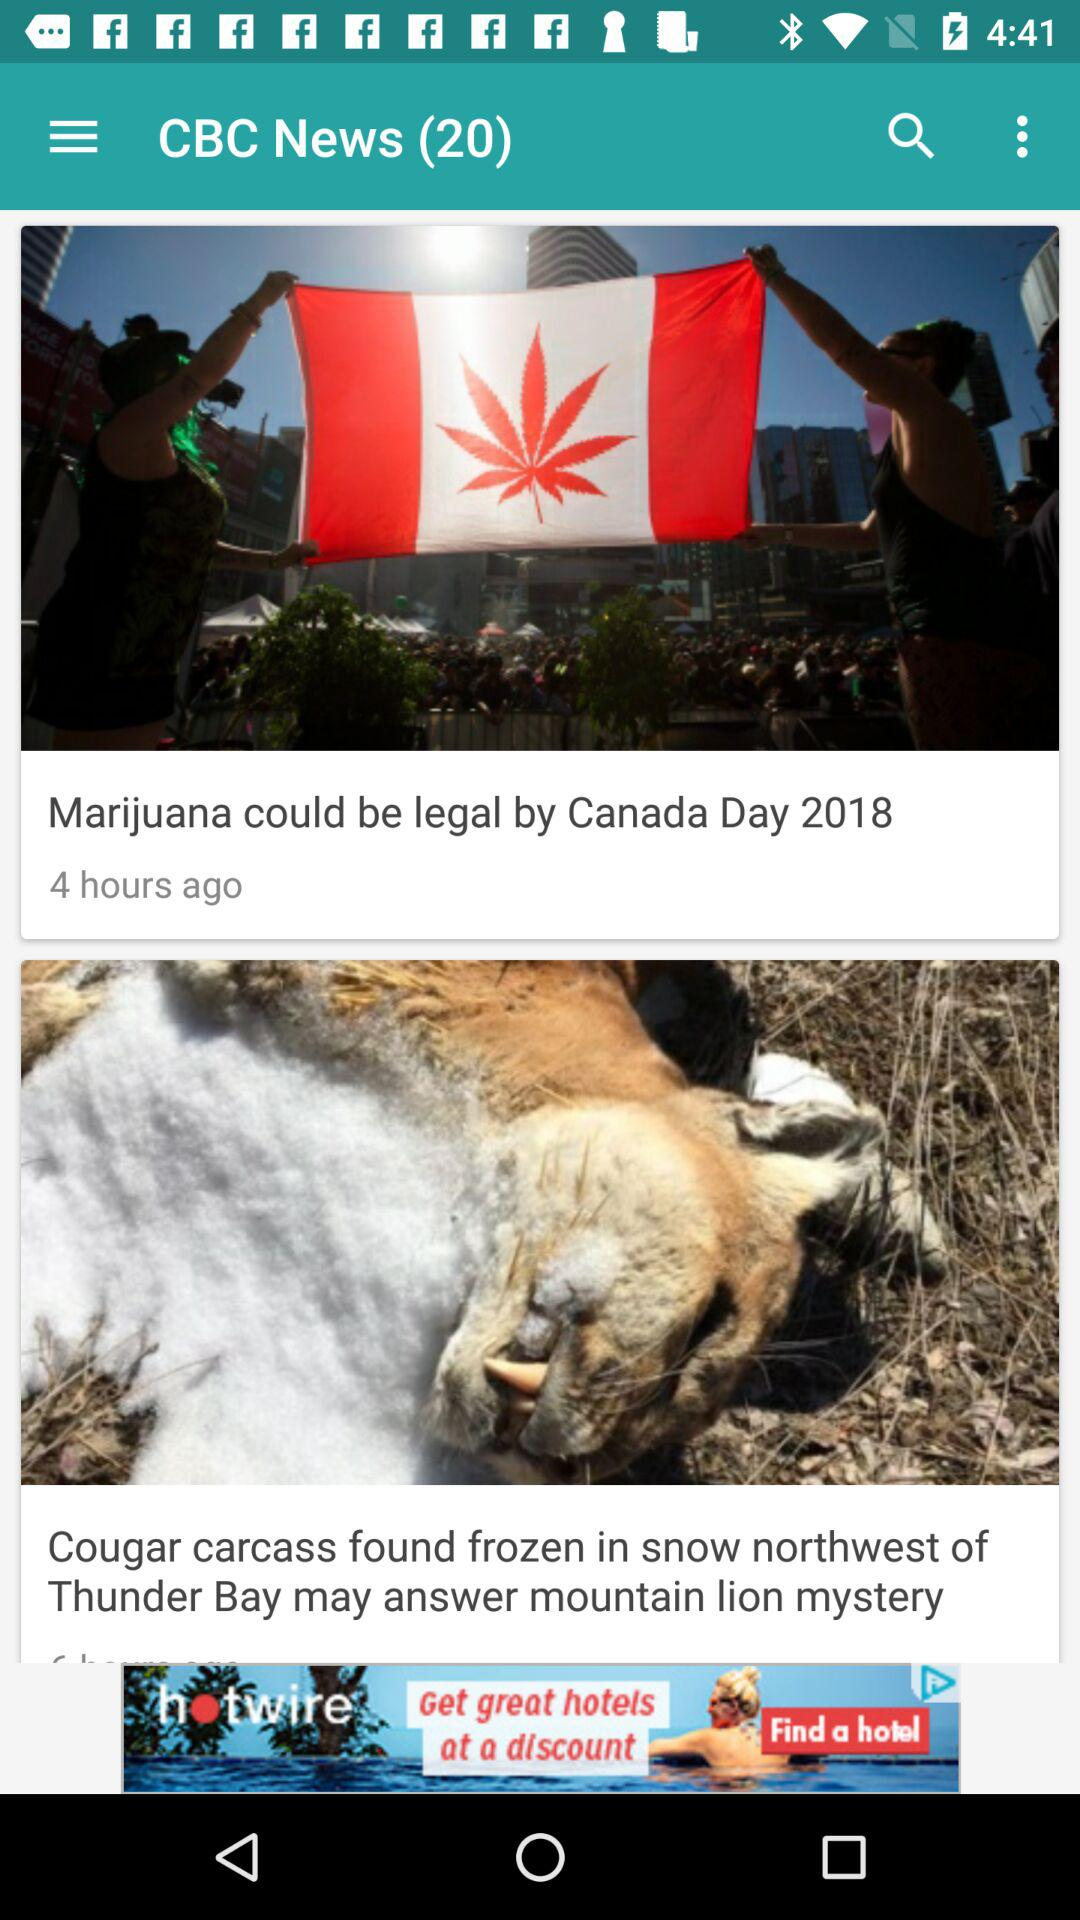What is the headline of the news posted 4 hours ago? The headline is "Marijuana could be legal by Canada Day 2018". 